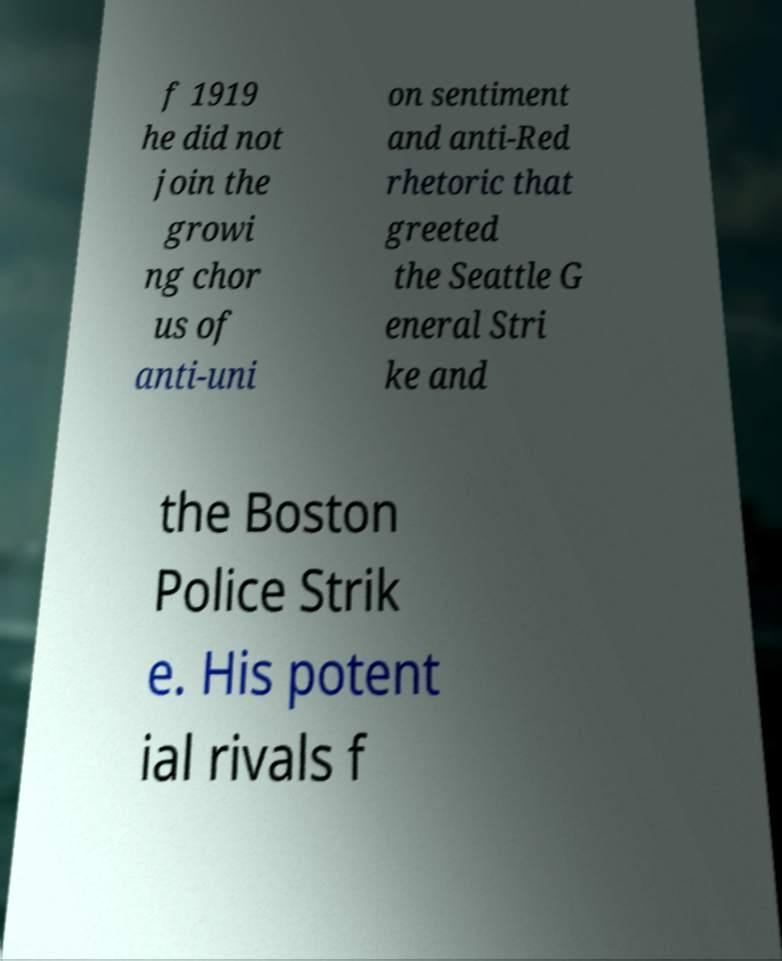Can you accurately transcribe the text from the provided image for me? f 1919 he did not join the growi ng chor us of anti-uni on sentiment and anti-Red rhetoric that greeted the Seattle G eneral Stri ke and the Boston Police Strik e. His potent ial rivals f 